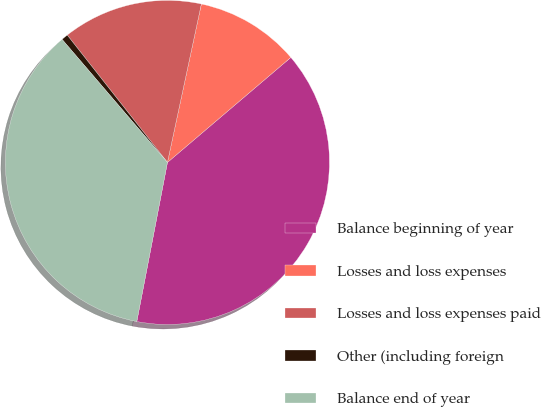Convert chart to OTSL. <chart><loc_0><loc_0><loc_500><loc_500><pie_chart><fcel>Balance beginning of year<fcel>Losses and loss expenses<fcel>Losses and loss expenses paid<fcel>Other (including foreign<fcel>Balance end of year<nl><fcel>39.25%<fcel>10.42%<fcel>13.97%<fcel>0.66%<fcel>35.7%<nl></chart> 